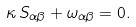Convert formula to latex. <formula><loc_0><loc_0><loc_500><loc_500>\kappa \, S _ { \alpha \beta } + \omega _ { \alpha \beta } = 0 .</formula> 